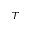Convert formula to latex. <formula><loc_0><loc_0><loc_500><loc_500>T</formula> 